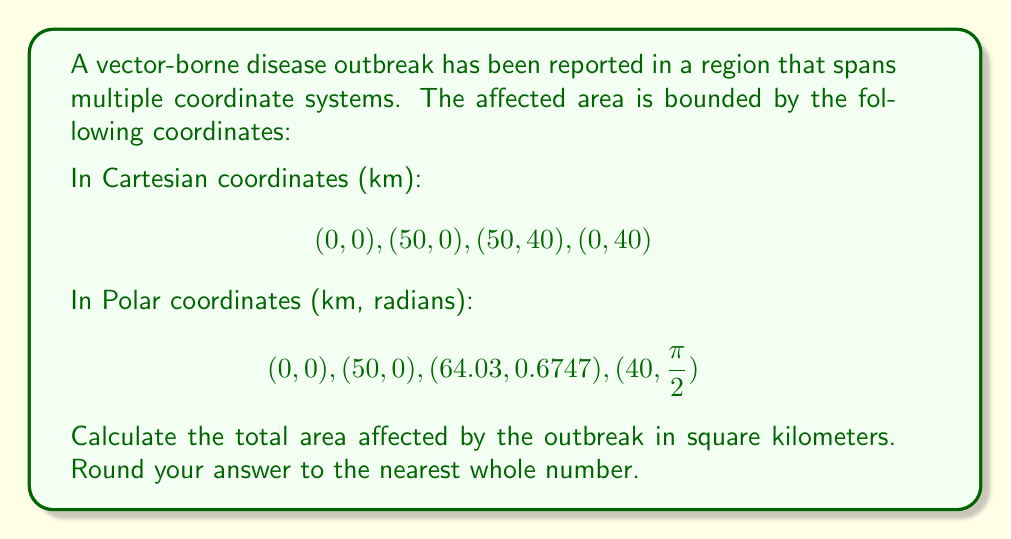Give your solution to this math problem. To solve this problem, we need to follow these steps:

1) First, we recognize that the area described in both coordinate systems is a quadrilateral.

2) In Cartesian coordinates, we have a rectangle. The area of a rectangle is simply length * width.

   Area = 50 km * 40 km = 2000 km²

3) In Polar coordinates, we have an irregular quadrilateral. We can calculate its area using the formula:

   $$A = \frac{1}{2} \sum_{i=1}^{n} (r_i r_{i+1} \sin(\theta_{i+1} - \theta_i))$$

   Where $r_i$ and $\theta_i$ are the radius and angle of the i-th point, respectively.

4) Let's calculate each term:

   $(r_1, \theta_1) = (0, 0)$
   $(r_2, \theta_2) = (50, 0)$
   $(r_3, \theta_3) = (64.03, 0.6747)$
   $(r_4, \theta_4) = (40, \frac{\pi}{2})$

   First term: $\frac{1}{2} * 0 * 50 * \sin(0 - 0) = 0$
   Second term: $\frac{1}{2} * 50 * 64.03 * \sin(0.6747 - 0) = 1000.47$
   Third term: $\frac{1}{2} * 64.03 * 40 * \sin(\frac{\pi}{2} - 0.6747) = 999.53$
   Fourth term: $\frac{1}{2} * 40 * 0 * \sin(0 - \frac{\pi}{2}) = 0$

5) Sum all terms:

   Total Area = 0 + 1000.47 + 999.53 + 0 = 2000 km²

6) Both coordinate systems yield the same result, confirming our calculation.
Answer: 2000 km² 